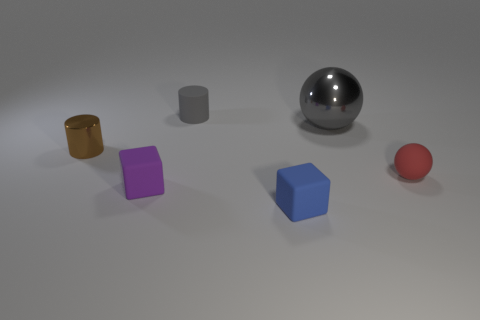There is a matte cylinder that is the same color as the big shiny thing; what size is it?
Your answer should be compact. Small. Is there anything else that has the same size as the gray metal ball?
Give a very brief answer. No. What number of other things are made of the same material as the brown cylinder?
Give a very brief answer. 1. How many objects are spheres that are behind the matte sphere or tiny brown metallic objects behind the small red matte ball?
Offer a very short reply. 2. There is a tiny red thing that is the same shape as the gray shiny object; what is it made of?
Offer a terse response. Rubber. Are there any green balls?
Your answer should be very brief. No. There is a matte thing that is both to the left of the tiny blue matte block and in front of the large metallic sphere; what size is it?
Keep it short and to the point. Small. The red thing has what shape?
Offer a terse response. Sphere. There is a sphere that is in front of the small shiny cylinder; are there any brown metal cylinders to the right of it?
Your answer should be compact. No. There is a purple block that is the same size as the rubber cylinder; what is its material?
Your answer should be very brief. Rubber. 